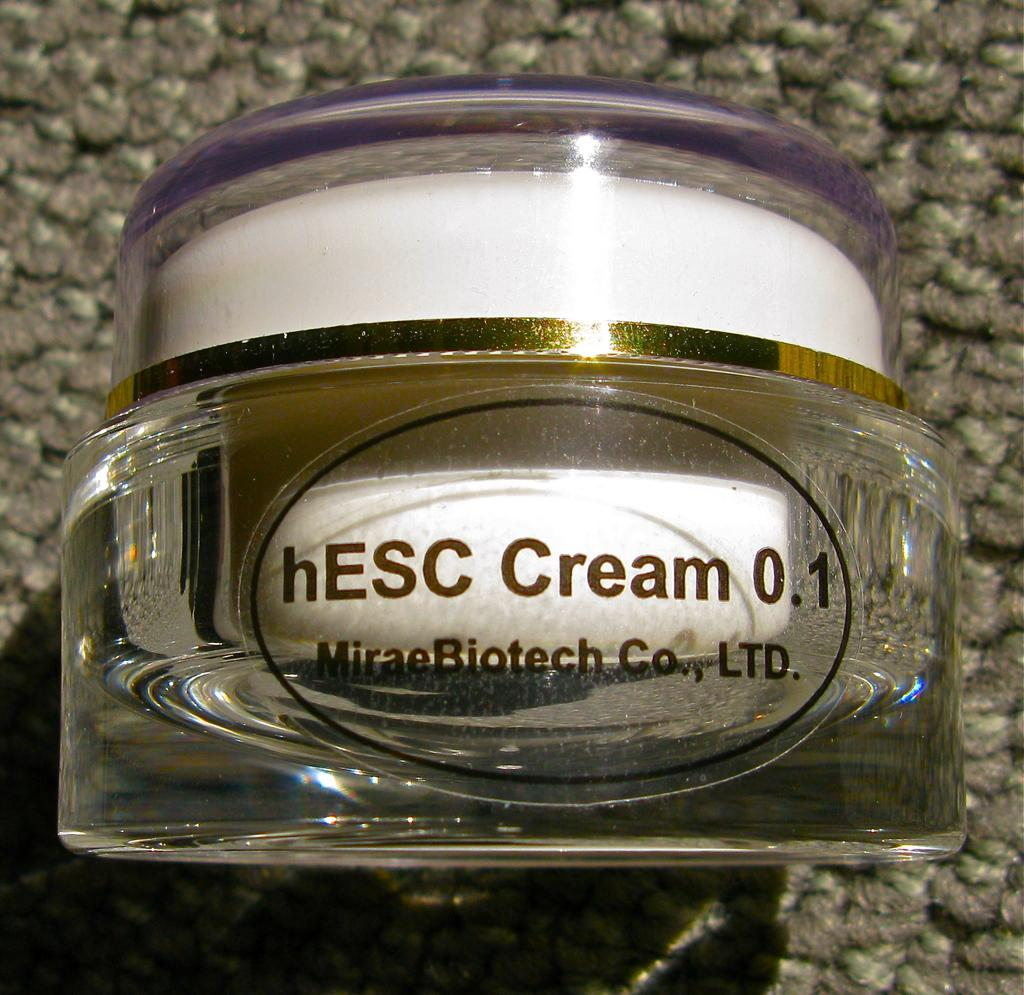Provide a one-sentence caption for the provided image. A small bottle of cream rests on a carpet floor. 